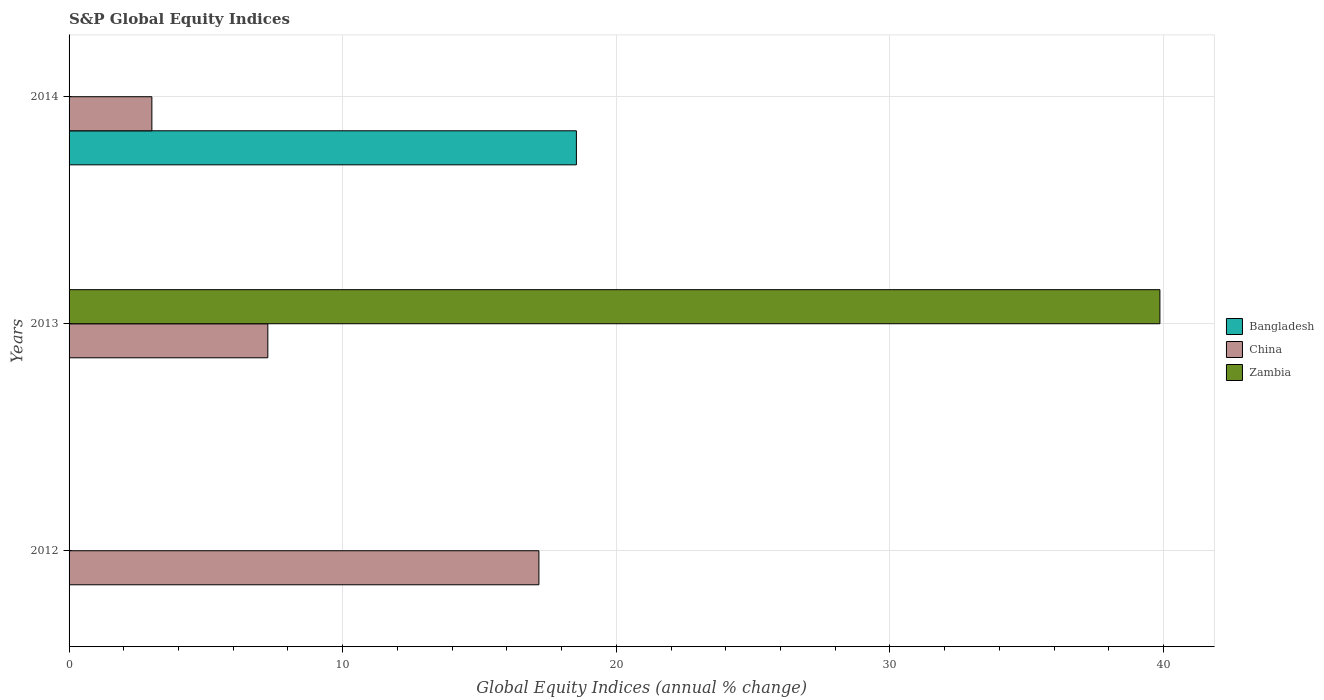How many bars are there on the 2nd tick from the top?
Ensure brevity in your answer.  2. What is the label of the 3rd group of bars from the top?
Make the answer very short. 2012. What is the global equity indices in Bangladesh in 2014?
Your answer should be very brief. 18.54. Across all years, what is the maximum global equity indices in China?
Offer a very short reply. 17.17. Across all years, what is the minimum global equity indices in Zambia?
Offer a very short reply. 0. In which year was the global equity indices in China maximum?
Provide a short and direct response. 2012. What is the total global equity indices in Bangladesh in the graph?
Offer a very short reply. 18.54. What is the difference between the global equity indices in China in 2013 and that in 2014?
Your answer should be compact. 4.24. What is the difference between the global equity indices in China in 2014 and the global equity indices in Zambia in 2013?
Give a very brief answer. -36.84. What is the average global equity indices in China per year?
Your response must be concise. 9.15. In the year 2014, what is the difference between the global equity indices in China and global equity indices in Bangladesh?
Provide a succinct answer. -15.51. What is the ratio of the global equity indices in China in 2012 to that in 2013?
Your answer should be very brief. 2.36. What is the difference between the highest and the second highest global equity indices in China?
Your answer should be compact. 9.91. What is the difference between the highest and the lowest global equity indices in China?
Offer a very short reply. 14.14. Is it the case that in every year, the sum of the global equity indices in China and global equity indices in Zambia is greater than the global equity indices in Bangladesh?
Offer a very short reply. No. How many bars are there?
Ensure brevity in your answer.  5. How many years are there in the graph?
Provide a short and direct response. 3. What is the difference between two consecutive major ticks on the X-axis?
Give a very brief answer. 10. Does the graph contain any zero values?
Your answer should be compact. Yes. Does the graph contain grids?
Offer a very short reply. Yes. Where does the legend appear in the graph?
Your answer should be compact. Center right. How many legend labels are there?
Provide a short and direct response. 3. How are the legend labels stacked?
Ensure brevity in your answer.  Vertical. What is the title of the graph?
Make the answer very short. S&P Global Equity Indices. What is the label or title of the X-axis?
Your answer should be very brief. Global Equity Indices (annual % change). What is the Global Equity Indices (annual % change) of Bangladesh in 2012?
Offer a very short reply. 0. What is the Global Equity Indices (annual % change) of China in 2012?
Provide a short and direct response. 17.17. What is the Global Equity Indices (annual % change) of China in 2013?
Ensure brevity in your answer.  7.26. What is the Global Equity Indices (annual % change) in Zambia in 2013?
Ensure brevity in your answer.  39.87. What is the Global Equity Indices (annual % change) of Bangladesh in 2014?
Your response must be concise. 18.54. What is the Global Equity Indices (annual % change) of China in 2014?
Your answer should be very brief. 3.03. What is the Global Equity Indices (annual % change) in Zambia in 2014?
Your response must be concise. 0. Across all years, what is the maximum Global Equity Indices (annual % change) in Bangladesh?
Your answer should be compact. 18.54. Across all years, what is the maximum Global Equity Indices (annual % change) in China?
Provide a succinct answer. 17.17. Across all years, what is the maximum Global Equity Indices (annual % change) of Zambia?
Your response must be concise. 39.87. Across all years, what is the minimum Global Equity Indices (annual % change) in Bangladesh?
Make the answer very short. 0. Across all years, what is the minimum Global Equity Indices (annual % change) of China?
Offer a terse response. 3.03. What is the total Global Equity Indices (annual % change) in Bangladesh in the graph?
Ensure brevity in your answer.  18.54. What is the total Global Equity Indices (annual % change) of China in the graph?
Provide a short and direct response. 27.46. What is the total Global Equity Indices (annual % change) in Zambia in the graph?
Your answer should be very brief. 39.87. What is the difference between the Global Equity Indices (annual % change) in China in 2012 and that in 2013?
Offer a very short reply. 9.91. What is the difference between the Global Equity Indices (annual % change) in China in 2012 and that in 2014?
Provide a short and direct response. 14.14. What is the difference between the Global Equity Indices (annual % change) in China in 2013 and that in 2014?
Make the answer very short. 4.24. What is the difference between the Global Equity Indices (annual % change) in China in 2012 and the Global Equity Indices (annual % change) in Zambia in 2013?
Offer a very short reply. -22.7. What is the average Global Equity Indices (annual % change) in Bangladesh per year?
Offer a terse response. 6.18. What is the average Global Equity Indices (annual % change) in China per year?
Your response must be concise. 9.15. What is the average Global Equity Indices (annual % change) of Zambia per year?
Ensure brevity in your answer.  13.29. In the year 2013, what is the difference between the Global Equity Indices (annual % change) of China and Global Equity Indices (annual % change) of Zambia?
Provide a succinct answer. -32.6. In the year 2014, what is the difference between the Global Equity Indices (annual % change) of Bangladesh and Global Equity Indices (annual % change) of China?
Give a very brief answer. 15.52. What is the ratio of the Global Equity Indices (annual % change) in China in 2012 to that in 2013?
Provide a short and direct response. 2.36. What is the ratio of the Global Equity Indices (annual % change) in China in 2012 to that in 2014?
Your answer should be very brief. 5.67. What is the ratio of the Global Equity Indices (annual % change) in China in 2013 to that in 2014?
Provide a succinct answer. 2.4. What is the difference between the highest and the second highest Global Equity Indices (annual % change) in China?
Provide a succinct answer. 9.91. What is the difference between the highest and the lowest Global Equity Indices (annual % change) in Bangladesh?
Your answer should be very brief. 18.54. What is the difference between the highest and the lowest Global Equity Indices (annual % change) of China?
Provide a short and direct response. 14.14. What is the difference between the highest and the lowest Global Equity Indices (annual % change) of Zambia?
Ensure brevity in your answer.  39.87. 